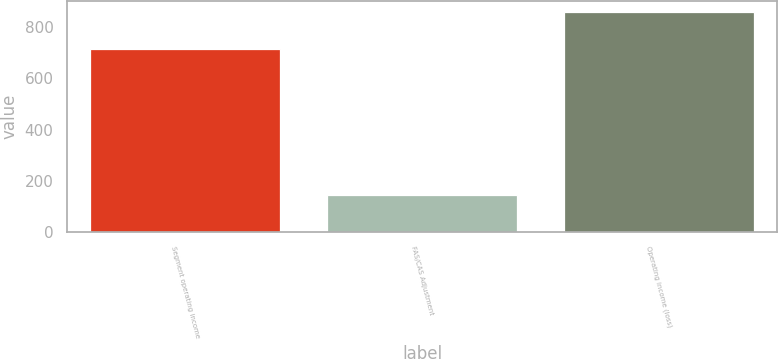Convert chart to OTSL. <chart><loc_0><loc_0><loc_500><loc_500><bar_chart><fcel>Segment operating income<fcel>FAS/CAS Adjustment<fcel>Operating income (loss)<nl><fcel>715<fcel>145<fcel>858<nl></chart> 